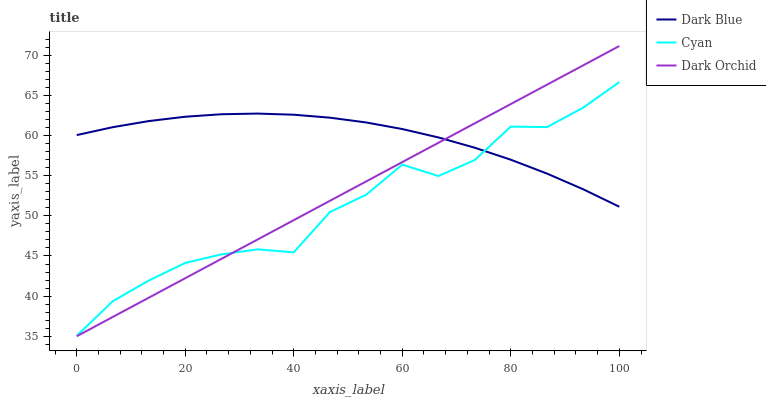Does Cyan have the minimum area under the curve?
Answer yes or no. Yes. Does Dark Blue have the maximum area under the curve?
Answer yes or no. Yes. Does Dark Orchid have the minimum area under the curve?
Answer yes or no. No. Does Dark Orchid have the maximum area under the curve?
Answer yes or no. No. Is Dark Orchid the smoothest?
Answer yes or no. Yes. Is Cyan the roughest?
Answer yes or no. Yes. Is Cyan the smoothest?
Answer yes or no. No. Is Dark Orchid the roughest?
Answer yes or no. No. Does Dark Orchid have the lowest value?
Answer yes or no. Yes. Does Cyan have the lowest value?
Answer yes or no. No. Does Dark Orchid have the highest value?
Answer yes or no. Yes. Does Cyan have the highest value?
Answer yes or no. No. Does Dark Blue intersect Dark Orchid?
Answer yes or no. Yes. Is Dark Blue less than Dark Orchid?
Answer yes or no. No. Is Dark Blue greater than Dark Orchid?
Answer yes or no. No. 